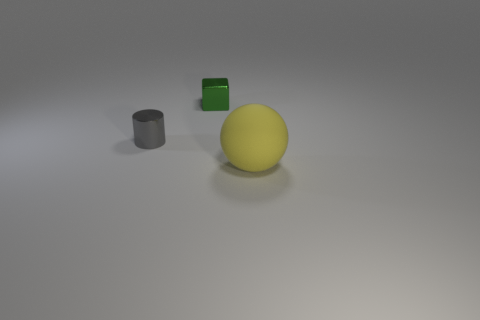Add 3 blue matte cylinders. How many objects exist? 6 Subtract 1 blocks. How many blocks are left? 0 Add 3 purple cubes. How many purple cubes exist? 3 Subtract 1 gray cylinders. How many objects are left? 2 Subtract all cubes. How many objects are left? 2 Subtract all blue spheres. Subtract all purple cylinders. How many spheres are left? 1 Subtract all cyan blocks. How many cyan cylinders are left? 0 Subtract all large blue rubber cylinders. Subtract all cubes. How many objects are left? 2 Add 3 yellow rubber balls. How many yellow rubber balls are left? 4 